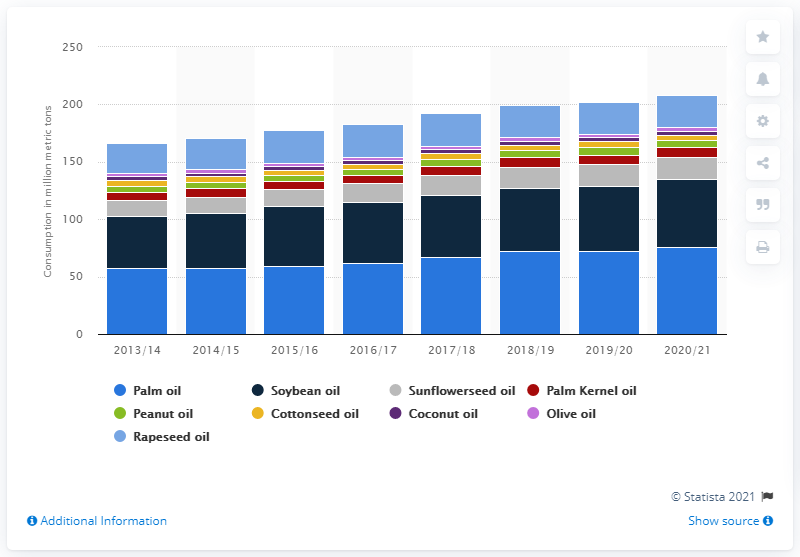Mention a couple of crucial points in this snapshot. The global consumption of sunflowerseed oil in the year 2020/21 was approximately 19.02 million metric tons. 